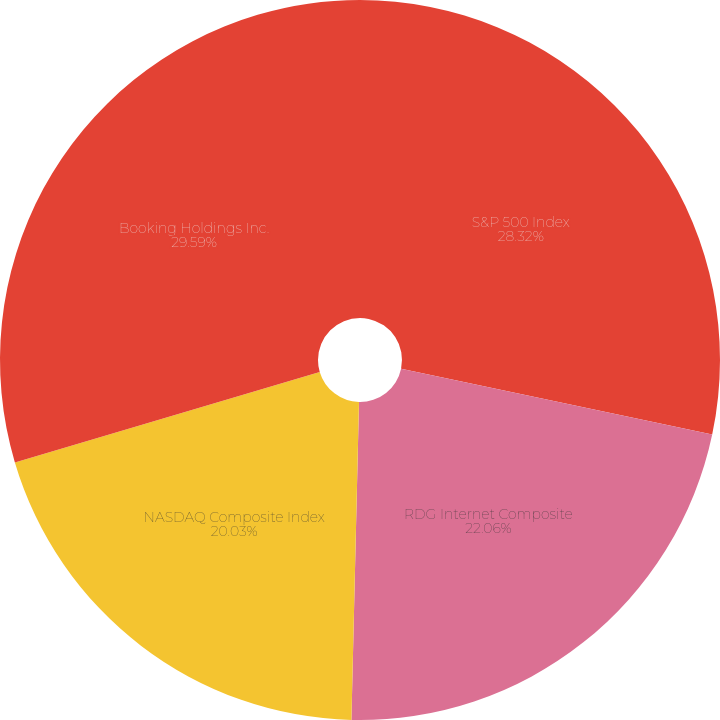<chart> <loc_0><loc_0><loc_500><loc_500><pie_chart><fcel>S&P 500 Index<fcel>RDG Internet Composite<fcel>NASDAQ Composite Index<fcel>Booking Holdings Inc.<nl><fcel>28.32%<fcel>22.06%<fcel>20.03%<fcel>29.59%<nl></chart> 